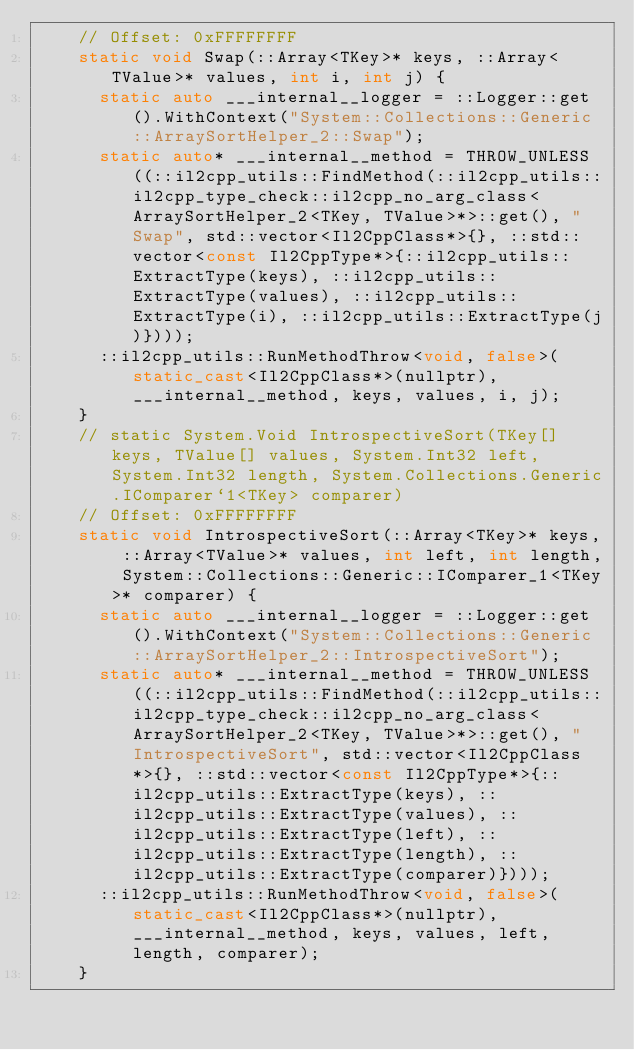Convert code to text. <code><loc_0><loc_0><loc_500><loc_500><_C++_>    // Offset: 0xFFFFFFFF
    static void Swap(::Array<TKey>* keys, ::Array<TValue>* values, int i, int j) {
      static auto ___internal__logger = ::Logger::get().WithContext("System::Collections::Generic::ArraySortHelper_2::Swap");
      static auto* ___internal__method = THROW_UNLESS((::il2cpp_utils::FindMethod(::il2cpp_utils::il2cpp_type_check::il2cpp_no_arg_class<ArraySortHelper_2<TKey, TValue>*>::get(), "Swap", std::vector<Il2CppClass*>{}, ::std::vector<const Il2CppType*>{::il2cpp_utils::ExtractType(keys), ::il2cpp_utils::ExtractType(values), ::il2cpp_utils::ExtractType(i), ::il2cpp_utils::ExtractType(j)})));
      ::il2cpp_utils::RunMethodThrow<void, false>(static_cast<Il2CppClass*>(nullptr), ___internal__method, keys, values, i, j);
    }
    // static System.Void IntrospectiveSort(TKey[] keys, TValue[] values, System.Int32 left, System.Int32 length, System.Collections.Generic.IComparer`1<TKey> comparer)
    // Offset: 0xFFFFFFFF
    static void IntrospectiveSort(::Array<TKey>* keys, ::Array<TValue>* values, int left, int length, System::Collections::Generic::IComparer_1<TKey>* comparer) {
      static auto ___internal__logger = ::Logger::get().WithContext("System::Collections::Generic::ArraySortHelper_2::IntrospectiveSort");
      static auto* ___internal__method = THROW_UNLESS((::il2cpp_utils::FindMethod(::il2cpp_utils::il2cpp_type_check::il2cpp_no_arg_class<ArraySortHelper_2<TKey, TValue>*>::get(), "IntrospectiveSort", std::vector<Il2CppClass*>{}, ::std::vector<const Il2CppType*>{::il2cpp_utils::ExtractType(keys), ::il2cpp_utils::ExtractType(values), ::il2cpp_utils::ExtractType(left), ::il2cpp_utils::ExtractType(length), ::il2cpp_utils::ExtractType(comparer)})));
      ::il2cpp_utils::RunMethodThrow<void, false>(static_cast<Il2CppClass*>(nullptr), ___internal__method, keys, values, left, length, comparer);
    }</code> 